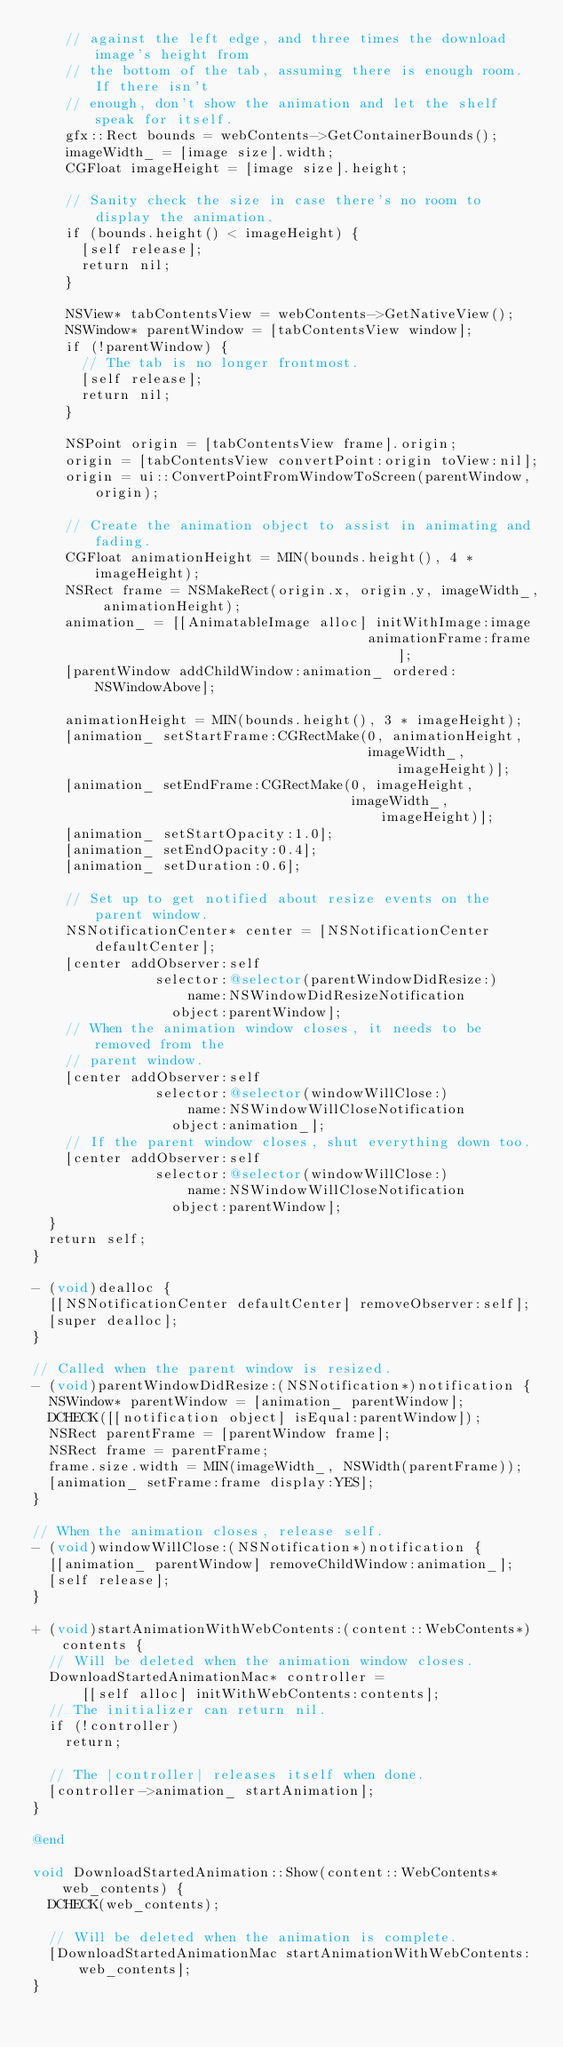Convert code to text. <code><loc_0><loc_0><loc_500><loc_500><_ObjectiveC_>    // against the left edge, and three times the download image's height from
    // the bottom of the tab, assuming there is enough room. If there isn't
    // enough, don't show the animation and let the shelf speak for itself.
    gfx::Rect bounds = webContents->GetContainerBounds();
    imageWidth_ = [image size].width;
    CGFloat imageHeight = [image size].height;

    // Sanity check the size in case there's no room to display the animation.
    if (bounds.height() < imageHeight) {
      [self release];
      return nil;
    }

    NSView* tabContentsView = webContents->GetNativeView();
    NSWindow* parentWindow = [tabContentsView window];
    if (!parentWindow) {
      // The tab is no longer frontmost.
      [self release];
      return nil;
    }

    NSPoint origin = [tabContentsView frame].origin;
    origin = [tabContentsView convertPoint:origin toView:nil];
    origin = ui::ConvertPointFromWindowToScreen(parentWindow, origin);

    // Create the animation object to assist in animating and fading.
    CGFloat animationHeight = MIN(bounds.height(), 4 * imageHeight);
    NSRect frame = NSMakeRect(origin.x, origin.y, imageWidth_, animationHeight);
    animation_ = [[AnimatableImage alloc] initWithImage:image
                                         animationFrame:frame];
    [parentWindow addChildWindow:animation_ ordered:NSWindowAbove];

    animationHeight = MIN(bounds.height(), 3 * imageHeight);
    [animation_ setStartFrame:CGRectMake(0, animationHeight,
                                         imageWidth_, imageHeight)];
    [animation_ setEndFrame:CGRectMake(0, imageHeight,
                                       imageWidth_, imageHeight)];
    [animation_ setStartOpacity:1.0];
    [animation_ setEndOpacity:0.4];
    [animation_ setDuration:0.6];

    // Set up to get notified about resize events on the parent window.
    NSNotificationCenter* center = [NSNotificationCenter defaultCenter];
    [center addObserver:self
               selector:@selector(parentWindowDidResize:)
                   name:NSWindowDidResizeNotification
                 object:parentWindow];
    // When the animation window closes, it needs to be removed from the
    // parent window.
    [center addObserver:self
               selector:@selector(windowWillClose:)
                   name:NSWindowWillCloseNotification
                 object:animation_];
    // If the parent window closes, shut everything down too.
    [center addObserver:self
               selector:@selector(windowWillClose:)
                   name:NSWindowWillCloseNotification
                 object:parentWindow];
  }
  return self;
}

- (void)dealloc {
  [[NSNotificationCenter defaultCenter] removeObserver:self];
  [super dealloc];
}

// Called when the parent window is resized.
- (void)parentWindowDidResize:(NSNotification*)notification {
  NSWindow* parentWindow = [animation_ parentWindow];
  DCHECK([[notification object] isEqual:parentWindow]);
  NSRect parentFrame = [parentWindow frame];
  NSRect frame = parentFrame;
  frame.size.width = MIN(imageWidth_, NSWidth(parentFrame));
  [animation_ setFrame:frame display:YES];
}

// When the animation closes, release self.
- (void)windowWillClose:(NSNotification*)notification {
  [[animation_ parentWindow] removeChildWindow:animation_];
  [self release];
}

+ (void)startAnimationWithWebContents:(content::WebContents*)contents {
  // Will be deleted when the animation window closes.
  DownloadStartedAnimationMac* controller =
      [[self alloc] initWithWebContents:contents];
  // The initializer can return nil.
  if (!controller)
    return;

  // The |controller| releases itself when done.
  [controller->animation_ startAnimation];
}

@end

void DownloadStartedAnimation::Show(content::WebContents* web_contents) {
  DCHECK(web_contents);

  // Will be deleted when the animation is complete.
  [DownloadStartedAnimationMac startAnimationWithWebContents:web_contents];
}
</code> 